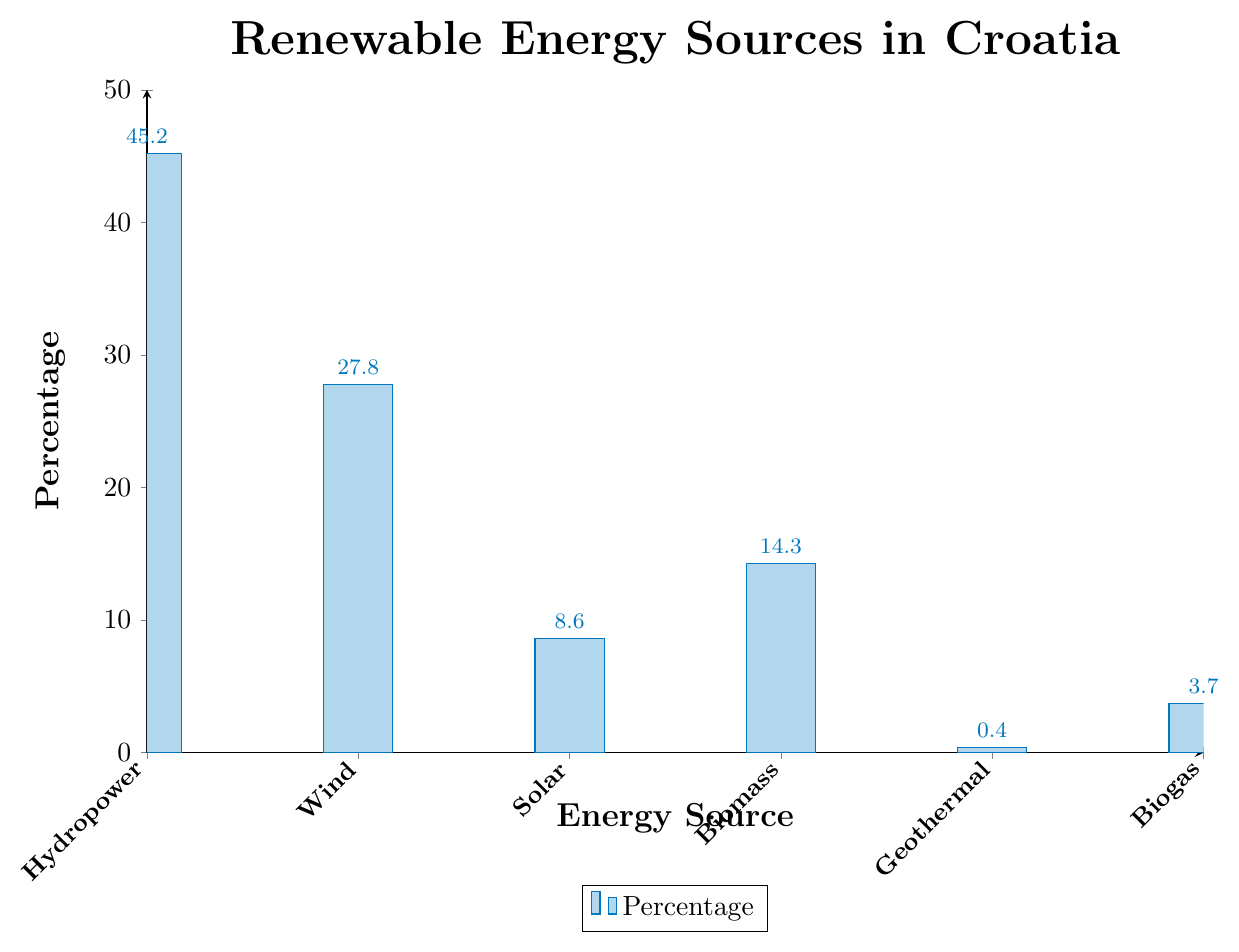Which energy source has the highest percentage in Croatia? Look at the bar that reaches the highest point on the chart, which represents Hydropower with a percentage of 45.2.
Answer: Hydropower Which energy source has the lowest percentage in Croatia? Look at the shortest bar on the chart, which represents Geothermal with a percentage of 0.4.
Answer: Geothermal How much more percentage does Hydropower have compared to Solar energy? Subtract the percentage of Solar energy (8.6) from the percentage of Hydropower (45.2). The difference is 45.2 - 8.6 = 36.6.
Answer: 36.6 What is the total percentage of Wind and Biomass energy sources combined? Add the percentage of Wind (27.8) and Biomass (14.3) together. The total is 27.8 + 14.3 = 42.1.
Answer: 42.1 Which energy sources have a percentage less than 10%? Identify the bars that have a height representing less than 10%. These are Solar (8.6), Geothermal (0.4), and Biogas (3.7).
Answer: Solar, Geothermal, Biogas Compare the percentage of Wind and Biomass energy sources. Which one is higher, and by how much? Wind has a percentage of 27.8, whereas Biomass has a percentage of 14.3. Subtract Biomass from Wind: 27.8 - 14.3 = 13.5. Wind has a higher percentage by 13.5 points.
Answer: Wind by 13.5 What is the average percentage of all renewable energy sources? Add up all the percentages: 45.2 (Hydropower) + 27.8 (Wind) + 8.6 (Solar) + 14.3 (Biomass) + 0.4 (Geothermal) + 3.7 (Biogas) = 100 and then divide by the number of sources (6). The average is 100 / 6 = 16.67.
Answer: 16.67 Which energy source has a percentage roughly half of Hydropower's percentage? Hydropower percentage is 45.2. Half of this is roughly 22.6. The closest percentage is Wind with 27.8.
Answer: Wind By how much does the percentage of Biogas exceed Geothermal? Subtract the percentage of Geothermal (0.4) from Biogas (3.7). The difference is 3.7 - 0.4 = 3.3.
Answer: 3.3 If you combine the percentages of the three least used energy sources, what is their total percentage? Add the percentages of Solar (8.6), Geothermal (0.4), and Biogas (3.7). The total is 8.6 + 0.4 + 3.7 = 12.7.
Answer: 12.7 